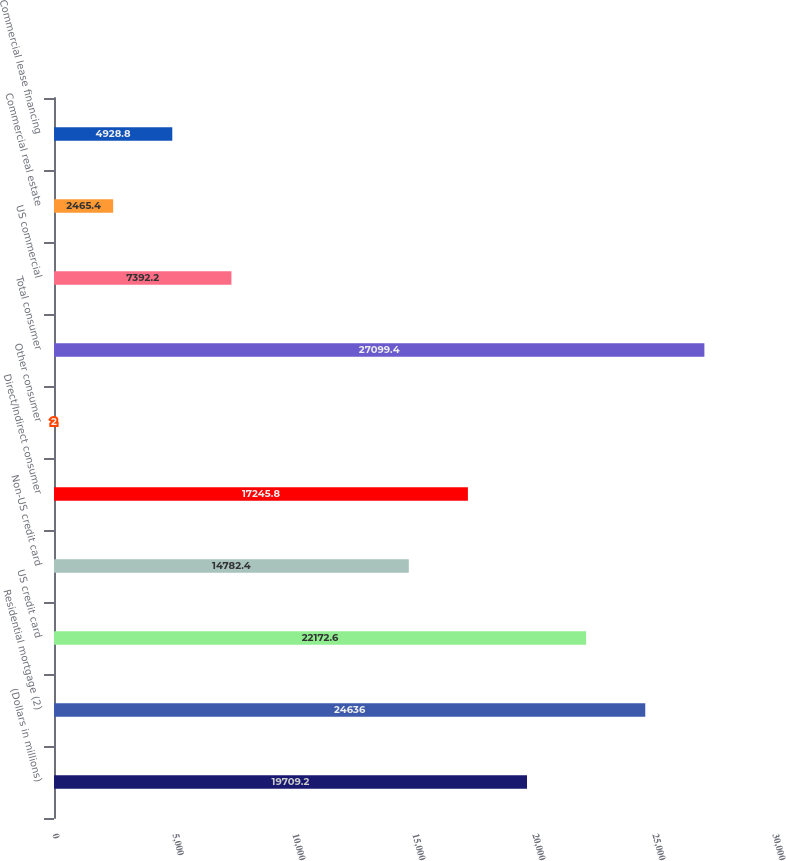<chart> <loc_0><loc_0><loc_500><loc_500><bar_chart><fcel>(Dollars in millions)<fcel>Residential mortgage (2)<fcel>US credit card<fcel>Non-US credit card<fcel>Direct/Indirect consumer<fcel>Other consumer<fcel>Total consumer<fcel>US commercial<fcel>Commercial real estate<fcel>Commercial lease financing<nl><fcel>19709.2<fcel>24636<fcel>22172.6<fcel>14782.4<fcel>17245.8<fcel>2<fcel>27099.4<fcel>7392.2<fcel>2465.4<fcel>4928.8<nl></chart> 